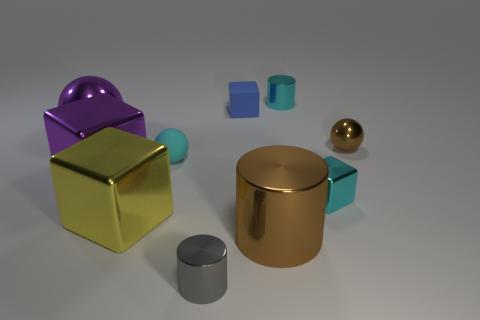Subtract all red cylinders. Subtract all red cubes. How many cylinders are left? 3 Subtract all cylinders. How many objects are left? 7 Subtract all yellow metallic objects. Subtract all rubber spheres. How many objects are left? 8 Add 7 metallic blocks. How many metallic blocks are left? 10 Add 5 small purple cylinders. How many small purple cylinders exist? 5 Subtract 1 brown cylinders. How many objects are left? 9 